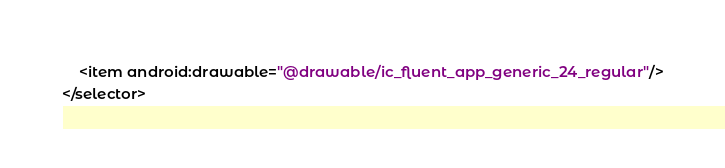<code> <loc_0><loc_0><loc_500><loc_500><_XML_>    <item android:drawable="@drawable/ic_fluent_app_generic_24_regular"/>
</selector>
</code> 